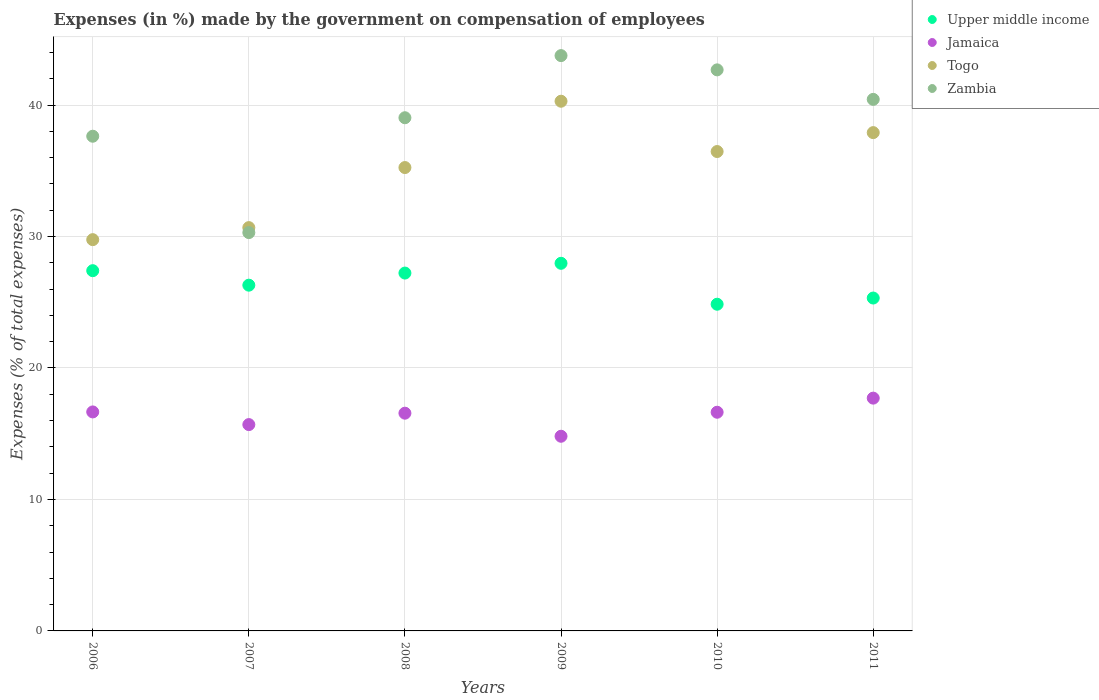How many different coloured dotlines are there?
Your answer should be compact. 4. What is the percentage of expenses made by the government on compensation of employees in Zambia in 2009?
Provide a short and direct response. 43.76. Across all years, what is the maximum percentage of expenses made by the government on compensation of employees in Upper middle income?
Your answer should be compact. 27.96. Across all years, what is the minimum percentage of expenses made by the government on compensation of employees in Upper middle income?
Your response must be concise. 24.85. What is the total percentage of expenses made by the government on compensation of employees in Zambia in the graph?
Ensure brevity in your answer.  233.83. What is the difference between the percentage of expenses made by the government on compensation of employees in Jamaica in 2006 and that in 2010?
Offer a very short reply. 0.02. What is the difference between the percentage of expenses made by the government on compensation of employees in Zambia in 2007 and the percentage of expenses made by the government on compensation of employees in Upper middle income in 2010?
Your answer should be very brief. 5.45. What is the average percentage of expenses made by the government on compensation of employees in Jamaica per year?
Keep it short and to the point. 16.34. In the year 2011, what is the difference between the percentage of expenses made by the government on compensation of employees in Upper middle income and percentage of expenses made by the government on compensation of employees in Togo?
Offer a very short reply. -12.58. What is the ratio of the percentage of expenses made by the government on compensation of employees in Upper middle income in 2007 to that in 2010?
Provide a short and direct response. 1.06. What is the difference between the highest and the second highest percentage of expenses made by the government on compensation of employees in Zambia?
Your response must be concise. 1.08. What is the difference between the highest and the lowest percentage of expenses made by the government on compensation of employees in Upper middle income?
Your response must be concise. 3.11. In how many years, is the percentage of expenses made by the government on compensation of employees in Zambia greater than the average percentage of expenses made by the government on compensation of employees in Zambia taken over all years?
Make the answer very short. 4. Is the sum of the percentage of expenses made by the government on compensation of employees in Jamaica in 2007 and 2011 greater than the maximum percentage of expenses made by the government on compensation of employees in Upper middle income across all years?
Your answer should be very brief. Yes. Is it the case that in every year, the sum of the percentage of expenses made by the government on compensation of employees in Jamaica and percentage of expenses made by the government on compensation of employees in Zambia  is greater than the sum of percentage of expenses made by the government on compensation of employees in Upper middle income and percentage of expenses made by the government on compensation of employees in Togo?
Offer a very short reply. No. Is it the case that in every year, the sum of the percentage of expenses made by the government on compensation of employees in Jamaica and percentage of expenses made by the government on compensation of employees in Zambia  is greater than the percentage of expenses made by the government on compensation of employees in Upper middle income?
Keep it short and to the point. Yes. Does the percentage of expenses made by the government on compensation of employees in Zambia monotonically increase over the years?
Your response must be concise. No. Is the percentage of expenses made by the government on compensation of employees in Zambia strictly greater than the percentage of expenses made by the government on compensation of employees in Togo over the years?
Your answer should be very brief. No. How many dotlines are there?
Offer a very short reply. 4. How many years are there in the graph?
Ensure brevity in your answer.  6. What is the difference between two consecutive major ticks on the Y-axis?
Your answer should be very brief. 10. Where does the legend appear in the graph?
Your response must be concise. Top right. How are the legend labels stacked?
Your answer should be very brief. Vertical. What is the title of the graph?
Your answer should be compact. Expenses (in %) made by the government on compensation of employees. What is the label or title of the Y-axis?
Your response must be concise. Expenses (% of total expenses). What is the Expenses (% of total expenses) in Upper middle income in 2006?
Ensure brevity in your answer.  27.4. What is the Expenses (% of total expenses) in Jamaica in 2006?
Offer a very short reply. 16.66. What is the Expenses (% of total expenses) in Togo in 2006?
Your response must be concise. 29.76. What is the Expenses (% of total expenses) of Zambia in 2006?
Make the answer very short. 37.63. What is the Expenses (% of total expenses) of Upper middle income in 2007?
Your response must be concise. 26.3. What is the Expenses (% of total expenses) in Jamaica in 2007?
Keep it short and to the point. 15.69. What is the Expenses (% of total expenses) of Togo in 2007?
Your response must be concise. 30.68. What is the Expenses (% of total expenses) of Zambia in 2007?
Provide a short and direct response. 30.3. What is the Expenses (% of total expenses) in Upper middle income in 2008?
Provide a short and direct response. 27.22. What is the Expenses (% of total expenses) in Jamaica in 2008?
Provide a succinct answer. 16.56. What is the Expenses (% of total expenses) in Togo in 2008?
Offer a terse response. 35.25. What is the Expenses (% of total expenses) in Zambia in 2008?
Provide a succinct answer. 39.03. What is the Expenses (% of total expenses) of Upper middle income in 2009?
Provide a succinct answer. 27.96. What is the Expenses (% of total expenses) of Jamaica in 2009?
Offer a very short reply. 14.81. What is the Expenses (% of total expenses) of Togo in 2009?
Provide a short and direct response. 40.29. What is the Expenses (% of total expenses) in Zambia in 2009?
Ensure brevity in your answer.  43.76. What is the Expenses (% of total expenses) in Upper middle income in 2010?
Your answer should be compact. 24.85. What is the Expenses (% of total expenses) of Jamaica in 2010?
Your answer should be very brief. 16.63. What is the Expenses (% of total expenses) of Togo in 2010?
Your answer should be very brief. 36.46. What is the Expenses (% of total expenses) in Zambia in 2010?
Offer a very short reply. 42.68. What is the Expenses (% of total expenses) in Upper middle income in 2011?
Ensure brevity in your answer.  25.32. What is the Expenses (% of total expenses) in Jamaica in 2011?
Keep it short and to the point. 17.71. What is the Expenses (% of total expenses) in Togo in 2011?
Provide a short and direct response. 37.9. What is the Expenses (% of total expenses) in Zambia in 2011?
Make the answer very short. 40.43. Across all years, what is the maximum Expenses (% of total expenses) in Upper middle income?
Offer a terse response. 27.96. Across all years, what is the maximum Expenses (% of total expenses) in Jamaica?
Offer a terse response. 17.71. Across all years, what is the maximum Expenses (% of total expenses) in Togo?
Provide a succinct answer. 40.29. Across all years, what is the maximum Expenses (% of total expenses) in Zambia?
Provide a short and direct response. 43.76. Across all years, what is the minimum Expenses (% of total expenses) of Upper middle income?
Offer a terse response. 24.85. Across all years, what is the minimum Expenses (% of total expenses) of Jamaica?
Give a very brief answer. 14.81. Across all years, what is the minimum Expenses (% of total expenses) in Togo?
Keep it short and to the point. 29.76. Across all years, what is the minimum Expenses (% of total expenses) in Zambia?
Your answer should be very brief. 30.3. What is the total Expenses (% of total expenses) of Upper middle income in the graph?
Your answer should be very brief. 159.05. What is the total Expenses (% of total expenses) in Jamaica in the graph?
Your answer should be compact. 98.06. What is the total Expenses (% of total expenses) of Togo in the graph?
Keep it short and to the point. 210.34. What is the total Expenses (% of total expenses) in Zambia in the graph?
Provide a short and direct response. 233.83. What is the difference between the Expenses (% of total expenses) in Upper middle income in 2006 and that in 2007?
Keep it short and to the point. 1.1. What is the difference between the Expenses (% of total expenses) of Togo in 2006 and that in 2007?
Provide a succinct answer. -0.92. What is the difference between the Expenses (% of total expenses) in Zambia in 2006 and that in 2007?
Offer a very short reply. 7.33. What is the difference between the Expenses (% of total expenses) in Upper middle income in 2006 and that in 2008?
Make the answer very short. 0.18. What is the difference between the Expenses (% of total expenses) in Jamaica in 2006 and that in 2008?
Ensure brevity in your answer.  0.1. What is the difference between the Expenses (% of total expenses) of Togo in 2006 and that in 2008?
Your answer should be very brief. -5.48. What is the difference between the Expenses (% of total expenses) of Zambia in 2006 and that in 2008?
Provide a succinct answer. -1.41. What is the difference between the Expenses (% of total expenses) of Upper middle income in 2006 and that in 2009?
Make the answer very short. -0.56. What is the difference between the Expenses (% of total expenses) in Jamaica in 2006 and that in 2009?
Provide a short and direct response. 1.85. What is the difference between the Expenses (% of total expenses) of Togo in 2006 and that in 2009?
Offer a very short reply. -10.53. What is the difference between the Expenses (% of total expenses) of Zambia in 2006 and that in 2009?
Offer a terse response. -6.13. What is the difference between the Expenses (% of total expenses) of Upper middle income in 2006 and that in 2010?
Your answer should be very brief. 2.55. What is the difference between the Expenses (% of total expenses) of Jamaica in 2006 and that in 2010?
Provide a succinct answer. 0.02. What is the difference between the Expenses (% of total expenses) of Togo in 2006 and that in 2010?
Your answer should be very brief. -6.7. What is the difference between the Expenses (% of total expenses) in Zambia in 2006 and that in 2010?
Make the answer very short. -5.05. What is the difference between the Expenses (% of total expenses) of Upper middle income in 2006 and that in 2011?
Provide a short and direct response. 2.08. What is the difference between the Expenses (% of total expenses) of Jamaica in 2006 and that in 2011?
Your answer should be compact. -1.05. What is the difference between the Expenses (% of total expenses) in Togo in 2006 and that in 2011?
Offer a very short reply. -8.14. What is the difference between the Expenses (% of total expenses) of Zambia in 2006 and that in 2011?
Offer a very short reply. -2.8. What is the difference between the Expenses (% of total expenses) in Upper middle income in 2007 and that in 2008?
Your answer should be very brief. -0.92. What is the difference between the Expenses (% of total expenses) in Jamaica in 2007 and that in 2008?
Your answer should be compact. -0.87. What is the difference between the Expenses (% of total expenses) in Togo in 2007 and that in 2008?
Keep it short and to the point. -4.57. What is the difference between the Expenses (% of total expenses) in Zambia in 2007 and that in 2008?
Offer a very short reply. -8.74. What is the difference between the Expenses (% of total expenses) in Upper middle income in 2007 and that in 2009?
Your answer should be very brief. -1.66. What is the difference between the Expenses (% of total expenses) in Jamaica in 2007 and that in 2009?
Make the answer very short. 0.89. What is the difference between the Expenses (% of total expenses) in Togo in 2007 and that in 2009?
Provide a short and direct response. -9.61. What is the difference between the Expenses (% of total expenses) of Zambia in 2007 and that in 2009?
Offer a very short reply. -13.46. What is the difference between the Expenses (% of total expenses) of Upper middle income in 2007 and that in 2010?
Your answer should be very brief. 1.45. What is the difference between the Expenses (% of total expenses) in Jamaica in 2007 and that in 2010?
Make the answer very short. -0.94. What is the difference between the Expenses (% of total expenses) in Togo in 2007 and that in 2010?
Make the answer very short. -5.79. What is the difference between the Expenses (% of total expenses) in Zambia in 2007 and that in 2010?
Make the answer very short. -12.38. What is the difference between the Expenses (% of total expenses) of Upper middle income in 2007 and that in 2011?
Keep it short and to the point. 0.98. What is the difference between the Expenses (% of total expenses) in Jamaica in 2007 and that in 2011?
Provide a short and direct response. -2.01. What is the difference between the Expenses (% of total expenses) in Togo in 2007 and that in 2011?
Give a very brief answer. -7.23. What is the difference between the Expenses (% of total expenses) in Zambia in 2007 and that in 2011?
Your answer should be very brief. -10.13. What is the difference between the Expenses (% of total expenses) in Upper middle income in 2008 and that in 2009?
Provide a succinct answer. -0.74. What is the difference between the Expenses (% of total expenses) in Jamaica in 2008 and that in 2009?
Your response must be concise. 1.75. What is the difference between the Expenses (% of total expenses) of Togo in 2008 and that in 2009?
Your answer should be very brief. -5.04. What is the difference between the Expenses (% of total expenses) of Zambia in 2008 and that in 2009?
Your response must be concise. -4.73. What is the difference between the Expenses (% of total expenses) in Upper middle income in 2008 and that in 2010?
Make the answer very short. 2.37. What is the difference between the Expenses (% of total expenses) in Jamaica in 2008 and that in 2010?
Your response must be concise. -0.07. What is the difference between the Expenses (% of total expenses) in Togo in 2008 and that in 2010?
Give a very brief answer. -1.22. What is the difference between the Expenses (% of total expenses) of Zambia in 2008 and that in 2010?
Provide a short and direct response. -3.64. What is the difference between the Expenses (% of total expenses) of Upper middle income in 2008 and that in 2011?
Your response must be concise. 1.9. What is the difference between the Expenses (% of total expenses) in Jamaica in 2008 and that in 2011?
Offer a very short reply. -1.15. What is the difference between the Expenses (% of total expenses) of Togo in 2008 and that in 2011?
Give a very brief answer. -2.66. What is the difference between the Expenses (% of total expenses) of Zambia in 2008 and that in 2011?
Your response must be concise. -1.4. What is the difference between the Expenses (% of total expenses) of Upper middle income in 2009 and that in 2010?
Your answer should be very brief. 3.11. What is the difference between the Expenses (% of total expenses) in Jamaica in 2009 and that in 2010?
Ensure brevity in your answer.  -1.83. What is the difference between the Expenses (% of total expenses) of Togo in 2009 and that in 2010?
Give a very brief answer. 3.83. What is the difference between the Expenses (% of total expenses) in Zambia in 2009 and that in 2010?
Your response must be concise. 1.08. What is the difference between the Expenses (% of total expenses) of Upper middle income in 2009 and that in 2011?
Your answer should be very brief. 2.64. What is the difference between the Expenses (% of total expenses) of Jamaica in 2009 and that in 2011?
Provide a succinct answer. -2.9. What is the difference between the Expenses (% of total expenses) in Togo in 2009 and that in 2011?
Give a very brief answer. 2.39. What is the difference between the Expenses (% of total expenses) in Zambia in 2009 and that in 2011?
Your answer should be compact. 3.33. What is the difference between the Expenses (% of total expenses) of Upper middle income in 2010 and that in 2011?
Offer a very short reply. -0.47. What is the difference between the Expenses (% of total expenses) in Jamaica in 2010 and that in 2011?
Offer a terse response. -1.07. What is the difference between the Expenses (% of total expenses) of Togo in 2010 and that in 2011?
Make the answer very short. -1.44. What is the difference between the Expenses (% of total expenses) in Zambia in 2010 and that in 2011?
Your answer should be very brief. 2.24. What is the difference between the Expenses (% of total expenses) of Upper middle income in 2006 and the Expenses (% of total expenses) of Jamaica in 2007?
Your answer should be very brief. 11.71. What is the difference between the Expenses (% of total expenses) of Upper middle income in 2006 and the Expenses (% of total expenses) of Togo in 2007?
Make the answer very short. -3.28. What is the difference between the Expenses (% of total expenses) of Upper middle income in 2006 and the Expenses (% of total expenses) of Zambia in 2007?
Offer a very short reply. -2.9. What is the difference between the Expenses (% of total expenses) in Jamaica in 2006 and the Expenses (% of total expenses) in Togo in 2007?
Make the answer very short. -14.02. What is the difference between the Expenses (% of total expenses) in Jamaica in 2006 and the Expenses (% of total expenses) in Zambia in 2007?
Your response must be concise. -13.64. What is the difference between the Expenses (% of total expenses) in Togo in 2006 and the Expenses (% of total expenses) in Zambia in 2007?
Make the answer very short. -0.54. What is the difference between the Expenses (% of total expenses) of Upper middle income in 2006 and the Expenses (% of total expenses) of Jamaica in 2008?
Offer a terse response. 10.84. What is the difference between the Expenses (% of total expenses) in Upper middle income in 2006 and the Expenses (% of total expenses) in Togo in 2008?
Provide a succinct answer. -7.84. What is the difference between the Expenses (% of total expenses) of Upper middle income in 2006 and the Expenses (% of total expenses) of Zambia in 2008?
Provide a succinct answer. -11.63. What is the difference between the Expenses (% of total expenses) of Jamaica in 2006 and the Expenses (% of total expenses) of Togo in 2008?
Give a very brief answer. -18.59. What is the difference between the Expenses (% of total expenses) of Jamaica in 2006 and the Expenses (% of total expenses) of Zambia in 2008?
Your response must be concise. -22.38. What is the difference between the Expenses (% of total expenses) in Togo in 2006 and the Expenses (% of total expenses) in Zambia in 2008?
Ensure brevity in your answer.  -9.27. What is the difference between the Expenses (% of total expenses) of Upper middle income in 2006 and the Expenses (% of total expenses) of Jamaica in 2009?
Ensure brevity in your answer.  12.59. What is the difference between the Expenses (% of total expenses) in Upper middle income in 2006 and the Expenses (% of total expenses) in Togo in 2009?
Give a very brief answer. -12.89. What is the difference between the Expenses (% of total expenses) in Upper middle income in 2006 and the Expenses (% of total expenses) in Zambia in 2009?
Give a very brief answer. -16.36. What is the difference between the Expenses (% of total expenses) of Jamaica in 2006 and the Expenses (% of total expenses) of Togo in 2009?
Keep it short and to the point. -23.63. What is the difference between the Expenses (% of total expenses) in Jamaica in 2006 and the Expenses (% of total expenses) in Zambia in 2009?
Provide a succinct answer. -27.1. What is the difference between the Expenses (% of total expenses) in Togo in 2006 and the Expenses (% of total expenses) in Zambia in 2009?
Your answer should be compact. -14. What is the difference between the Expenses (% of total expenses) in Upper middle income in 2006 and the Expenses (% of total expenses) in Jamaica in 2010?
Offer a very short reply. 10.77. What is the difference between the Expenses (% of total expenses) of Upper middle income in 2006 and the Expenses (% of total expenses) of Togo in 2010?
Give a very brief answer. -9.06. What is the difference between the Expenses (% of total expenses) of Upper middle income in 2006 and the Expenses (% of total expenses) of Zambia in 2010?
Your answer should be compact. -15.28. What is the difference between the Expenses (% of total expenses) of Jamaica in 2006 and the Expenses (% of total expenses) of Togo in 2010?
Your answer should be compact. -19.81. What is the difference between the Expenses (% of total expenses) in Jamaica in 2006 and the Expenses (% of total expenses) in Zambia in 2010?
Your answer should be compact. -26.02. What is the difference between the Expenses (% of total expenses) in Togo in 2006 and the Expenses (% of total expenses) in Zambia in 2010?
Give a very brief answer. -12.91. What is the difference between the Expenses (% of total expenses) in Upper middle income in 2006 and the Expenses (% of total expenses) in Jamaica in 2011?
Offer a terse response. 9.69. What is the difference between the Expenses (% of total expenses) of Upper middle income in 2006 and the Expenses (% of total expenses) of Togo in 2011?
Provide a succinct answer. -10.5. What is the difference between the Expenses (% of total expenses) of Upper middle income in 2006 and the Expenses (% of total expenses) of Zambia in 2011?
Your response must be concise. -13.03. What is the difference between the Expenses (% of total expenses) of Jamaica in 2006 and the Expenses (% of total expenses) of Togo in 2011?
Offer a very short reply. -21.25. What is the difference between the Expenses (% of total expenses) in Jamaica in 2006 and the Expenses (% of total expenses) in Zambia in 2011?
Your response must be concise. -23.77. What is the difference between the Expenses (% of total expenses) in Togo in 2006 and the Expenses (% of total expenses) in Zambia in 2011?
Ensure brevity in your answer.  -10.67. What is the difference between the Expenses (% of total expenses) of Upper middle income in 2007 and the Expenses (% of total expenses) of Jamaica in 2008?
Your answer should be compact. 9.74. What is the difference between the Expenses (% of total expenses) in Upper middle income in 2007 and the Expenses (% of total expenses) in Togo in 2008?
Provide a short and direct response. -8.95. What is the difference between the Expenses (% of total expenses) of Upper middle income in 2007 and the Expenses (% of total expenses) of Zambia in 2008?
Give a very brief answer. -12.74. What is the difference between the Expenses (% of total expenses) in Jamaica in 2007 and the Expenses (% of total expenses) in Togo in 2008?
Provide a succinct answer. -19.55. What is the difference between the Expenses (% of total expenses) in Jamaica in 2007 and the Expenses (% of total expenses) in Zambia in 2008?
Make the answer very short. -23.34. What is the difference between the Expenses (% of total expenses) of Togo in 2007 and the Expenses (% of total expenses) of Zambia in 2008?
Offer a very short reply. -8.36. What is the difference between the Expenses (% of total expenses) in Upper middle income in 2007 and the Expenses (% of total expenses) in Jamaica in 2009?
Your answer should be compact. 11.49. What is the difference between the Expenses (% of total expenses) in Upper middle income in 2007 and the Expenses (% of total expenses) in Togo in 2009?
Keep it short and to the point. -13.99. What is the difference between the Expenses (% of total expenses) in Upper middle income in 2007 and the Expenses (% of total expenses) in Zambia in 2009?
Provide a short and direct response. -17.46. What is the difference between the Expenses (% of total expenses) in Jamaica in 2007 and the Expenses (% of total expenses) in Togo in 2009?
Your answer should be compact. -24.6. What is the difference between the Expenses (% of total expenses) of Jamaica in 2007 and the Expenses (% of total expenses) of Zambia in 2009?
Give a very brief answer. -28.07. What is the difference between the Expenses (% of total expenses) in Togo in 2007 and the Expenses (% of total expenses) in Zambia in 2009?
Your answer should be very brief. -13.08. What is the difference between the Expenses (% of total expenses) in Upper middle income in 2007 and the Expenses (% of total expenses) in Jamaica in 2010?
Your answer should be compact. 9.67. What is the difference between the Expenses (% of total expenses) in Upper middle income in 2007 and the Expenses (% of total expenses) in Togo in 2010?
Provide a short and direct response. -10.17. What is the difference between the Expenses (% of total expenses) in Upper middle income in 2007 and the Expenses (% of total expenses) in Zambia in 2010?
Your answer should be very brief. -16.38. What is the difference between the Expenses (% of total expenses) in Jamaica in 2007 and the Expenses (% of total expenses) in Togo in 2010?
Ensure brevity in your answer.  -20.77. What is the difference between the Expenses (% of total expenses) of Jamaica in 2007 and the Expenses (% of total expenses) of Zambia in 2010?
Offer a terse response. -26.98. What is the difference between the Expenses (% of total expenses) in Togo in 2007 and the Expenses (% of total expenses) in Zambia in 2010?
Give a very brief answer. -12. What is the difference between the Expenses (% of total expenses) of Upper middle income in 2007 and the Expenses (% of total expenses) of Jamaica in 2011?
Provide a short and direct response. 8.59. What is the difference between the Expenses (% of total expenses) in Upper middle income in 2007 and the Expenses (% of total expenses) in Togo in 2011?
Ensure brevity in your answer.  -11.6. What is the difference between the Expenses (% of total expenses) of Upper middle income in 2007 and the Expenses (% of total expenses) of Zambia in 2011?
Make the answer very short. -14.13. What is the difference between the Expenses (% of total expenses) of Jamaica in 2007 and the Expenses (% of total expenses) of Togo in 2011?
Your response must be concise. -22.21. What is the difference between the Expenses (% of total expenses) of Jamaica in 2007 and the Expenses (% of total expenses) of Zambia in 2011?
Offer a very short reply. -24.74. What is the difference between the Expenses (% of total expenses) of Togo in 2007 and the Expenses (% of total expenses) of Zambia in 2011?
Ensure brevity in your answer.  -9.75. What is the difference between the Expenses (% of total expenses) of Upper middle income in 2008 and the Expenses (% of total expenses) of Jamaica in 2009?
Provide a succinct answer. 12.41. What is the difference between the Expenses (% of total expenses) of Upper middle income in 2008 and the Expenses (% of total expenses) of Togo in 2009?
Provide a short and direct response. -13.07. What is the difference between the Expenses (% of total expenses) in Upper middle income in 2008 and the Expenses (% of total expenses) in Zambia in 2009?
Make the answer very short. -16.54. What is the difference between the Expenses (% of total expenses) in Jamaica in 2008 and the Expenses (% of total expenses) in Togo in 2009?
Ensure brevity in your answer.  -23.73. What is the difference between the Expenses (% of total expenses) of Jamaica in 2008 and the Expenses (% of total expenses) of Zambia in 2009?
Your answer should be compact. -27.2. What is the difference between the Expenses (% of total expenses) of Togo in 2008 and the Expenses (% of total expenses) of Zambia in 2009?
Provide a short and direct response. -8.51. What is the difference between the Expenses (% of total expenses) in Upper middle income in 2008 and the Expenses (% of total expenses) in Jamaica in 2010?
Make the answer very short. 10.59. What is the difference between the Expenses (% of total expenses) of Upper middle income in 2008 and the Expenses (% of total expenses) of Togo in 2010?
Your response must be concise. -9.24. What is the difference between the Expenses (% of total expenses) in Upper middle income in 2008 and the Expenses (% of total expenses) in Zambia in 2010?
Your answer should be very brief. -15.46. What is the difference between the Expenses (% of total expenses) in Jamaica in 2008 and the Expenses (% of total expenses) in Togo in 2010?
Make the answer very short. -19.9. What is the difference between the Expenses (% of total expenses) in Jamaica in 2008 and the Expenses (% of total expenses) in Zambia in 2010?
Your response must be concise. -26.11. What is the difference between the Expenses (% of total expenses) of Togo in 2008 and the Expenses (% of total expenses) of Zambia in 2010?
Provide a succinct answer. -7.43. What is the difference between the Expenses (% of total expenses) in Upper middle income in 2008 and the Expenses (% of total expenses) in Jamaica in 2011?
Your answer should be compact. 9.51. What is the difference between the Expenses (% of total expenses) of Upper middle income in 2008 and the Expenses (% of total expenses) of Togo in 2011?
Provide a succinct answer. -10.68. What is the difference between the Expenses (% of total expenses) in Upper middle income in 2008 and the Expenses (% of total expenses) in Zambia in 2011?
Provide a short and direct response. -13.21. What is the difference between the Expenses (% of total expenses) in Jamaica in 2008 and the Expenses (% of total expenses) in Togo in 2011?
Make the answer very short. -21.34. What is the difference between the Expenses (% of total expenses) in Jamaica in 2008 and the Expenses (% of total expenses) in Zambia in 2011?
Offer a very short reply. -23.87. What is the difference between the Expenses (% of total expenses) in Togo in 2008 and the Expenses (% of total expenses) in Zambia in 2011?
Make the answer very short. -5.19. What is the difference between the Expenses (% of total expenses) in Upper middle income in 2009 and the Expenses (% of total expenses) in Jamaica in 2010?
Offer a terse response. 11.33. What is the difference between the Expenses (% of total expenses) of Upper middle income in 2009 and the Expenses (% of total expenses) of Togo in 2010?
Offer a very short reply. -8.5. What is the difference between the Expenses (% of total expenses) in Upper middle income in 2009 and the Expenses (% of total expenses) in Zambia in 2010?
Your response must be concise. -14.71. What is the difference between the Expenses (% of total expenses) in Jamaica in 2009 and the Expenses (% of total expenses) in Togo in 2010?
Keep it short and to the point. -21.66. What is the difference between the Expenses (% of total expenses) of Jamaica in 2009 and the Expenses (% of total expenses) of Zambia in 2010?
Keep it short and to the point. -27.87. What is the difference between the Expenses (% of total expenses) of Togo in 2009 and the Expenses (% of total expenses) of Zambia in 2010?
Keep it short and to the point. -2.39. What is the difference between the Expenses (% of total expenses) in Upper middle income in 2009 and the Expenses (% of total expenses) in Jamaica in 2011?
Keep it short and to the point. 10.26. What is the difference between the Expenses (% of total expenses) in Upper middle income in 2009 and the Expenses (% of total expenses) in Togo in 2011?
Keep it short and to the point. -9.94. What is the difference between the Expenses (% of total expenses) in Upper middle income in 2009 and the Expenses (% of total expenses) in Zambia in 2011?
Your answer should be compact. -12.47. What is the difference between the Expenses (% of total expenses) in Jamaica in 2009 and the Expenses (% of total expenses) in Togo in 2011?
Keep it short and to the point. -23.1. What is the difference between the Expenses (% of total expenses) in Jamaica in 2009 and the Expenses (% of total expenses) in Zambia in 2011?
Ensure brevity in your answer.  -25.62. What is the difference between the Expenses (% of total expenses) in Togo in 2009 and the Expenses (% of total expenses) in Zambia in 2011?
Your answer should be compact. -0.14. What is the difference between the Expenses (% of total expenses) in Upper middle income in 2010 and the Expenses (% of total expenses) in Jamaica in 2011?
Ensure brevity in your answer.  7.14. What is the difference between the Expenses (% of total expenses) in Upper middle income in 2010 and the Expenses (% of total expenses) in Togo in 2011?
Keep it short and to the point. -13.05. What is the difference between the Expenses (% of total expenses) of Upper middle income in 2010 and the Expenses (% of total expenses) of Zambia in 2011?
Provide a short and direct response. -15.58. What is the difference between the Expenses (% of total expenses) in Jamaica in 2010 and the Expenses (% of total expenses) in Togo in 2011?
Offer a very short reply. -21.27. What is the difference between the Expenses (% of total expenses) in Jamaica in 2010 and the Expenses (% of total expenses) in Zambia in 2011?
Give a very brief answer. -23.8. What is the difference between the Expenses (% of total expenses) in Togo in 2010 and the Expenses (% of total expenses) in Zambia in 2011?
Give a very brief answer. -3.97. What is the average Expenses (% of total expenses) in Upper middle income per year?
Give a very brief answer. 26.51. What is the average Expenses (% of total expenses) in Jamaica per year?
Your answer should be compact. 16.34. What is the average Expenses (% of total expenses) in Togo per year?
Offer a terse response. 35.06. What is the average Expenses (% of total expenses) of Zambia per year?
Offer a terse response. 38.97. In the year 2006, what is the difference between the Expenses (% of total expenses) in Upper middle income and Expenses (% of total expenses) in Jamaica?
Provide a succinct answer. 10.74. In the year 2006, what is the difference between the Expenses (% of total expenses) in Upper middle income and Expenses (% of total expenses) in Togo?
Provide a succinct answer. -2.36. In the year 2006, what is the difference between the Expenses (% of total expenses) in Upper middle income and Expenses (% of total expenses) in Zambia?
Your answer should be compact. -10.23. In the year 2006, what is the difference between the Expenses (% of total expenses) of Jamaica and Expenses (% of total expenses) of Togo?
Provide a succinct answer. -13.1. In the year 2006, what is the difference between the Expenses (% of total expenses) in Jamaica and Expenses (% of total expenses) in Zambia?
Your answer should be compact. -20.97. In the year 2006, what is the difference between the Expenses (% of total expenses) in Togo and Expenses (% of total expenses) in Zambia?
Ensure brevity in your answer.  -7.87. In the year 2007, what is the difference between the Expenses (% of total expenses) in Upper middle income and Expenses (% of total expenses) in Jamaica?
Provide a short and direct response. 10.6. In the year 2007, what is the difference between the Expenses (% of total expenses) in Upper middle income and Expenses (% of total expenses) in Togo?
Make the answer very short. -4.38. In the year 2007, what is the difference between the Expenses (% of total expenses) in Upper middle income and Expenses (% of total expenses) in Zambia?
Your answer should be very brief. -4. In the year 2007, what is the difference between the Expenses (% of total expenses) in Jamaica and Expenses (% of total expenses) in Togo?
Make the answer very short. -14.98. In the year 2007, what is the difference between the Expenses (% of total expenses) in Jamaica and Expenses (% of total expenses) in Zambia?
Your answer should be very brief. -14.6. In the year 2007, what is the difference between the Expenses (% of total expenses) of Togo and Expenses (% of total expenses) of Zambia?
Your answer should be very brief. 0.38. In the year 2008, what is the difference between the Expenses (% of total expenses) of Upper middle income and Expenses (% of total expenses) of Jamaica?
Your answer should be very brief. 10.66. In the year 2008, what is the difference between the Expenses (% of total expenses) of Upper middle income and Expenses (% of total expenses) of Togo?
Make the answer very short. -8.03. In the year 2008, what is the difference between the Expenses (% of total expenses) in Upper middle income and Expenses (% of total expenses) in Zambia?
Give a very brief answer. -11.81. In the year 2008, what is the difference between the Expenses (% of total expenses) of Jamaica and Expenses (% of total expenses) of Togo?
Ensure brevity in your answer.  -18.68. In the year 2008, what is the difference between the Expenses (% of total expenses) of Jamaica and Expenses (% of total expenses) of Zambia?
Offer a very short reply. -22.47. In the year 2008, what is the difference between the Expenses (% of total expenses) of Togo and Expenses (% of total expenses) of Zambia?
Keep it short and to the point. -3.79. In the year 2009, what is the difference between the Expenses (% of total expenses) of Upper middle income and Expenses (% of total expenses) of Jamaica?
Offer a terse response. 13.16. In the year 2009, what is the difference between the Expenses (% of total expenses) of Upper middle income and Expenses (% of total expenses) of Togo?
Provide a short and direct response. -12.33. In the year 2009, what is the difference between the Expenses (% of total expenses) in Upper middle income and Expenses (% of total expenses) in Zambia?
Provide a short and direct response. -15.8. In the year 2009, what is the difference between the Expenses (% of total expenses) in Jamaica and Expenses (% of total expenses) in Togo?
Ensure brevity in your answer.  -25.48. In the year 2009, what is the difference between the Expenses (% of total expenses) in Jamaica and Expenses (% of total expenses) in Zambia?
Provide a short and direct response. -28.95. In the year 2009, what is the difference between the Expenses (% of total expenses) in Togo and Expenses (% of total expenses) in Zambia?
Your answer should be compact. -3.47. In the year 2010, what is the difference between the Expenses (% of total expenses) in Upper middle income and Expenses (% of total expenses) in Jamaica?
Offer a terse response. 8.22. In the year 2010, what is the difference between the Expenses (% of total expenses) of Upper middle income and Expenses (% of total expenses) of Togo?
Make the answer very short. -11.62. In the year 2010, what is the difference between the Expenses (% of total expenses) in Upper middle income and Expenses (% of total expenses) in Zambia?
Your answer should be compact. -17.83. In the year 2010, what is the difference between the Expenses (% of total expenses) in Jamaica and Expenses (% of total expenses) in Togo?
Ensure brevity in your answer.  -19.83. In the year 2010, what is the difference between the Expenses (% of total expenses) of Jamaica and Expenses (% of total expenses) of Zambia?
Offer a terse response. -26.04. In the year 2010, what is the difference between the Expenses (% of total expenses) of Togo and Expenses (% of total expenses) of Zambia?
Your response must be concise. -6.21. In the year 2011, what is the difference between the Expenses (% of total expenses) in Upper middle income and Expenses (% of total expenses) in Jamaica?
Your answer should be compact. 7.61. In the year 2011, what is the difference between the Expenses (% of total expenses) in Upper middle income and Expenses (% of total expenses) in Togo?
Your answer should be compact. -12.58. In the year 2011, what is the difference between the Expenses (% of total expenses) of Upper middle income and Expenses (% of total expenses) of Zambia?
Provide a succinct answer. -15.11. In the year 2011, what is the difference between the Expenses (% of total expenses) of Jamaica and Expenses (% of total expenses) of Togo?
Your answer should be compact. -20.2. In the year 2011, what is the difference between the Expenses (% of total expenses) in Jamaica and Expenses (% of total expenses) in Zambia?
Ensure brevity in your answer.  -22.72. In the year 2011, what is the difference between the Expenses (% of total expenses) of Togo and Expenses (% of total expenses) of Zambia?
Offer a terse response. -2.53. What is the ratio of the Expenses (% of total expenses) of Upper middle income in 2006 to that in 2007?
Offer a terse response. 1.04. What is the ratio of the Expenses (% of total expenses) in Jamaica in 2006 to that in 2007?
Provide a short and direct response. 1.06. What is the ratio of the Expenses (% of total expenses) of Togo in 2006 to that in 2007?
Provide a succinct answer. 0.97. What is the ratio of the Expenses (% of total expenses) of Zambia in 2006 to that in 2007?
Offer a terse response. 1.24. What is the ratio of the Expenses (% of total expenses) in Upper middle income in 2006 to that in 2008?
Your answer should be compact. 1.01. What is the ratio of the Expenses (% of total expenses) in Jamaica in 2006 to that in 2008?
Offer a very short reply. 1.01. What is the ratio of the Expenses (% of total expenses) of Togo in 2006 to that in 2008?
Give a very brief answer. 0.84. What is the ratio of the Expenses (% of total expenses) in Zambia in 2006 to that in 2008?
Your response must be concise. 0.96. What is the ratio of the Expenses (% of total expenses) in Upper middle income in 2006 to that in 2009?
Ensure brevity in your answer.  0.98. What is the ratio of the Expenses (% of total expenses) in Togo in 2006 to that in 2009?
Your answer should be compact. 0.74. What is the ratio of the Expenses (% of total expenses) in Zambia in 2006 to that in 2009?
Offer a very short reply. 0.86. What is the ratio of the Expenses (% of total expenses) in Upper middle income in 2006 to that in 2010?
Your response must be concise. 1.1. What is the ratio of the Expenses (% of total expenses) of Jamaica in 2006 to that in 2010?
Your answer should be compact. 1. What is the ratio of the Expenses (% of total expenses) of Togo in 2006 to that in 2010?
Offer a terse response. 0.82. What is the ratio of the Expenses (% of total expenses) of Zambia in 2006 to that in 2010?
Your answer should be compact. 0.88. What is the ratio of the Expenses (% of total expenses) in Upper middle income in 2006 to that in 2011?
Provide a short and direct response. 1.08. What is the ratio of the Expenses (% of total expenses) of Jamaica in 2006 to that in 2011?
Offer a terse response. 0.94. What is the ratio of the Expenses (% of total expenses) in Togo in 2006 to that in 2011?
Your answer should be very brief. 0.79. What is the ratio of the Expenses (% of total expenses) in Zambia in 2006 to that in 2011?
Your answer should be very brief. 0.93. What is the ratio of the Expenses (% of total expenses) in Upper middle income in 2007 to that in 2008?
Your response must be concise. 0.97. What is the ratio of the Expenses (% of total expenses) in Jamaica in 2007 to that in 2008?
Ensure brevity in your answer.  0.95. What is the ratio of the Expenses (% of total expenses) in Togo in 2007 to that in 2008?
Ensure brevity in your answer.  0.87. What is the ratio of the Expenses (% of total expenses) in Zambia in 2007 to that in 2008?
Your answer should be very brief. 0.78. What is the ratio of the Expenses (% of total expenses) of Upper middle income in 2007 to that in 2009?
Provide a short and direct response. 0.94. What is the ratio of the Expenses (% of total expenses) of Jamaica in 2007 to that in 2009?
Provide a succinct answer. 1.06. What is the ratio of the Expenses (% of total expenses) in Togo in 2007 to that in 2009?
Your response must be concise. 0.76. What is the ratio of the Expenses (% of total expenses) of Zambia in 2007 to that in 2009?
Offer a very short reply. 0.69. What is the ratio of the Expenses (% of total expenses) in Upper middle income in 2007 to that in 2010?
Ensure brevity in your answer.  1.06. What is the ratio of the Expenses (% of total expenses) of Jamaica in 2007 to that in 2010?
Keep it short and to the point. 0.94. What is the ratio of the Expenses (% of total expenses) in Togo in 2007 to that in 2010?
Make the answer very short. 0.84. What is the ratio of the Expenses (% of total expenses) of Zambia in 2007 to that in 2010?
Provide a short and direct response. 0.71. What is the ratio of the Expenses (% of total expenses) of Upper middle income in 2007 to that in 2011?
Keep it short and to the point. 1.04. What is the ratio of the Expenses (% of total expenses) of Jamaica in 2007 to that in 2011?
Your answer should be compact. 0.89. What is the ratio of the Expenses (% of total expenses) of Togo in 2007 to that in 2011?
Offer a very short reply. 0.81. What is the ratio of the Expenses (% of total expenses) in Zambia in 2007 to that in 2011?
Ensure brevity in your answer.  0.75. What is the ratio of the Expenses (% of total expenses) of Upper middle income in 2008 to that in 2009?
Provide a succinct answer. 0.97. What is the ratio of the Expenses (% of total expenses) in Jamaica in 2008 to that in 2009?
Keep it short and to the point. 1.12. What is the ratio of the Expenses (% of total expenses) in Togo in 2008 to that in 2009?
Provide a succinct answer. 0.87. What is the ratio of the Expenses (% of total expenses) in Zambia in 2008 to that in 2009?
Your response must be concise. 0.89. What is the ratio of the Expenses (% of total expenses) in Upper middle income in 2008 to that in 2010?
Ensure brevity in your answer.  1.1. What is the ratio of the Expenses (% of total expenses) of Togo in 2008 to that in 2010?
Provide a short and direct response. 0.97. What is the ratio of the Expenses (% of total expenses) in Zambia in 2008 to that in 2010?
Keep it short and to the point. 0.91. What is the ratio of the Expenses (% of total expenses) in Upper middle income in 2008 to that in 2011?
Offer a very short reply. 1.07. What is the ratio of the Expenses (% of total expenses) in Jamaica in 2008 to that in 2011?
Offer a very short reply. 0.94. What is the ratio of the Expenses (% of total expenses) of Togo in 2008 to that in 2011?
Ensure brevity in your answer.  0.93. What is the ratio of the Expenses (% of total expenses) of Zambia in 2008 to that in 2011?
Your answer should be very brief. 0.97. What is the ratio of the Expenses (% of total expenses) of Upper middle income in 2009 to that in 2010?
Provide a succinct answer. 1.13. What is the ratio of the Expenses (% of total expenses) in Jamaica in 2009 to that in 2010?
Provide a succinct answer. 0.89. What is the ratio of the Expenses (% of total expenses) in Togo in 2009 to that in 2010?
Ensure brevity in your answer.  1.1. What is the ratio of the Expenses (% of total expenses) in Zambia in 2009 to that in 2010?
Your answer should be compact. 1.03. What is the ratio of the Expenses (% of total expenses) in Upper middle income in 2009 to that in 2011?
Give a very brief answer. 1.1. What is the ratio of the Expenses (% of total expenses) in Jamaica in 2009 to that in 2011?
Offer a very short reply. 0.84. What is the ratio of the Expenses (% of total expenses) in Togo in 2009 to that in 2011?
Your answer should be very brief. 1.06. What is the ratio of the Expenses (% of total expenses) of Zambia in 2009 to that in 2011?
Offer a very short reply. 1.08. What is the ratio of the Expenses (% of total expenses) in Upper middle income in 2010 to that in 2011?
Keep it short and to the point. 0.98. What is the ratio of the Expenses (% of total expenses) of Jamaica in 2010 to that in 2011?
Offer a very short reply. 0.94. What is the ratio of the Expenses (% of total expenses) of Zambia in 2010 to that in 2011?
Make the answer very short. 1.06. What is the difference between the highest and the second highest Expenses (% of total expenses) of Upper middle income?
Your answer should be compact. 0.56. What is the difference between the highest and the second highest Expenses (% of total expenses) in Jamaica?
Provide a succinct answer. 1.05. What is the difference between the highest and the second highest Expenses (% of total expenses) of Togo?
Your response must be concise. 2.39. What is the difference between the highest and the second highest Expenses (% of total expenses) of Zambia?
Make the answer very short. 1.08. What is the difference between the highest and the lowest Expenses (% of total expenses) in Upper middle income?
Offer a very short reply. 3.11. What is the difference between the highest and the lowest Expenses (% of total expenses) of Jamaica?
Offer a very short reply. 2.9. What is the difference between the highest and the lowest Expenses (% of total expenses) in Togo?
Your answer should be compact. 10.53. What is the difference between the highest and the lowest Expenses (% of total expenses) of Zambia?
Offer a terse response. 13.46. 